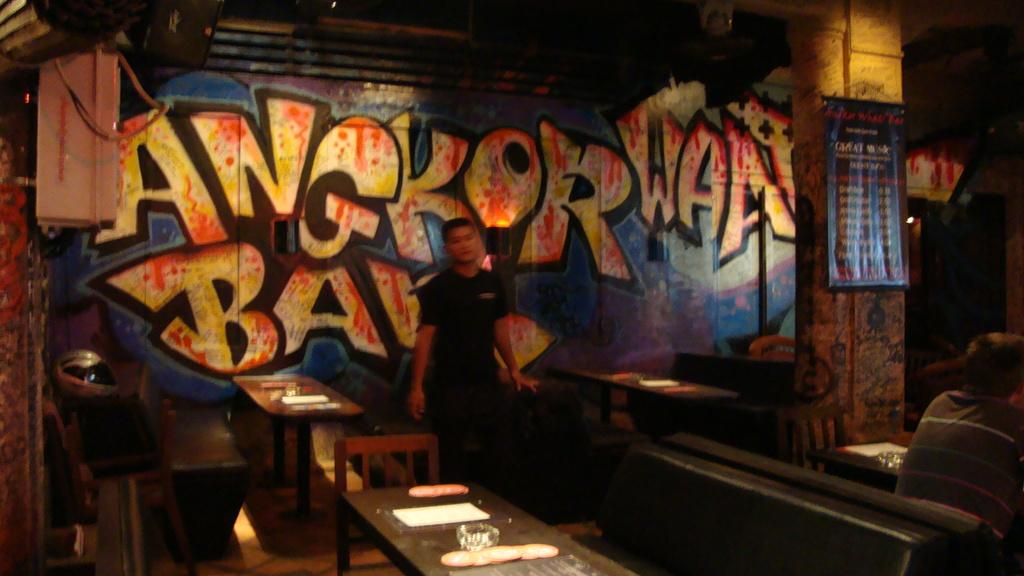What is the main subject of the image? There is a man standing in the image. Where is the man standing? The man is standing on the floor. What other furniture can be seen in the image? There are chairs and tables in the image. What is on one of the tables? There is a bowl on one of the tables. What can be seen in the background of the image? There is a wall and a banner in the background of the image. What type of soap is being used by the man in the image? There is no soap present in the image, as the man is standing and not engaged in any activity involving soap. 